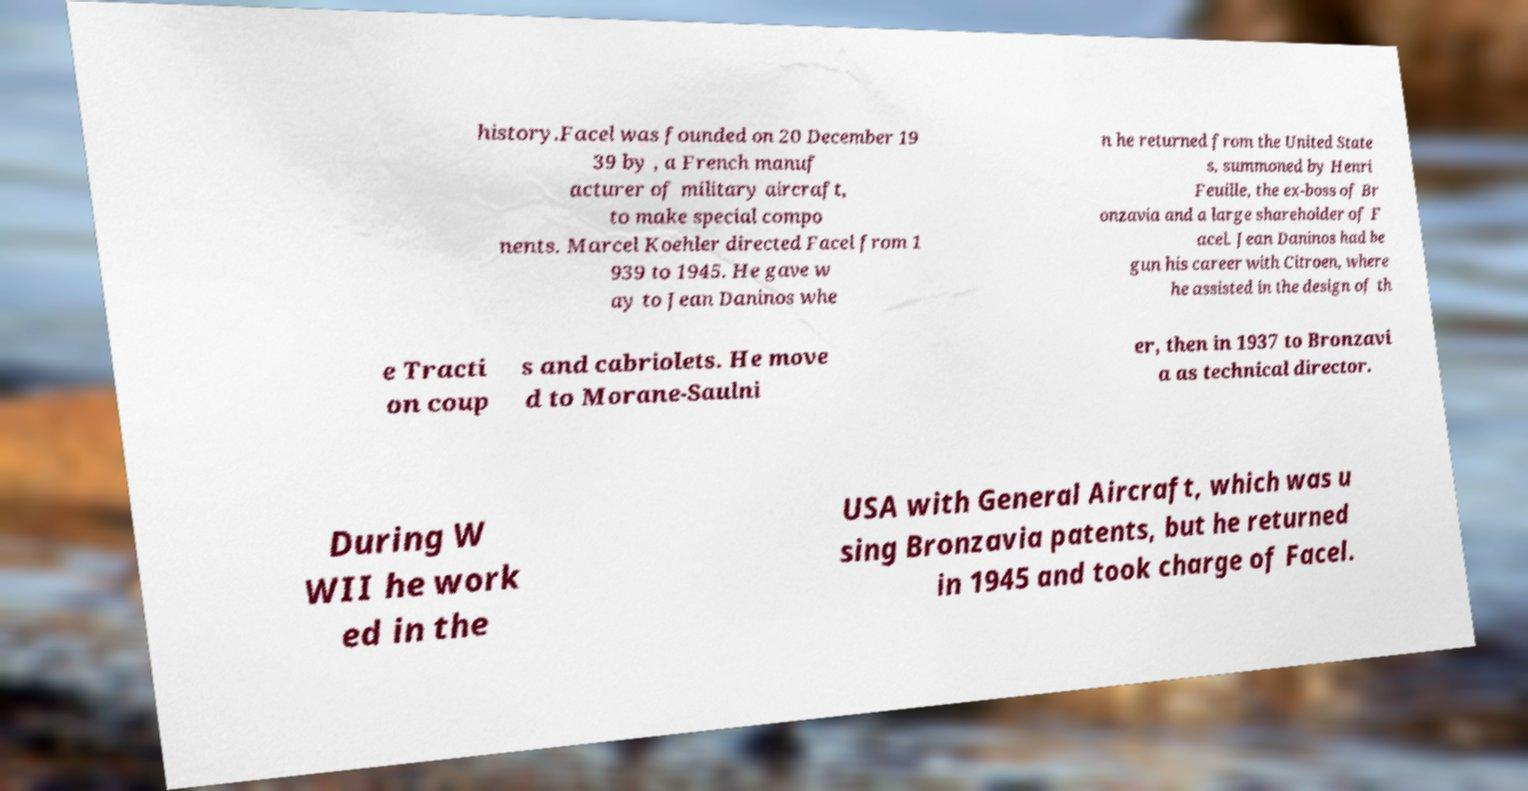I need the written content from this picture converted into text. Can you do that? history.Facel was founded on 20 December 19 39 by , a French manuf acturer of military aircraft, to make special compo nents. Marcel Koehler directed Facel from 1 939 to 1945. He gave w ay to Jean Daninos whe n he returned from the United State s, summoned by Henri Feuille, the ex-boss of Br onzavia and a large shareholder of F acel. Jean Daninos had be gun his career with Citroen, where he assisted in the design of th e Tracti on coup s and cabriolets. He move d to Morane-Saulni er, then in 1937 to Bronzavi a as technical director. During W WII he work ed in the USA with General Aircraft, which was u sing Bronzavia patents, but he returned in 1945 and took charge of Facel. 